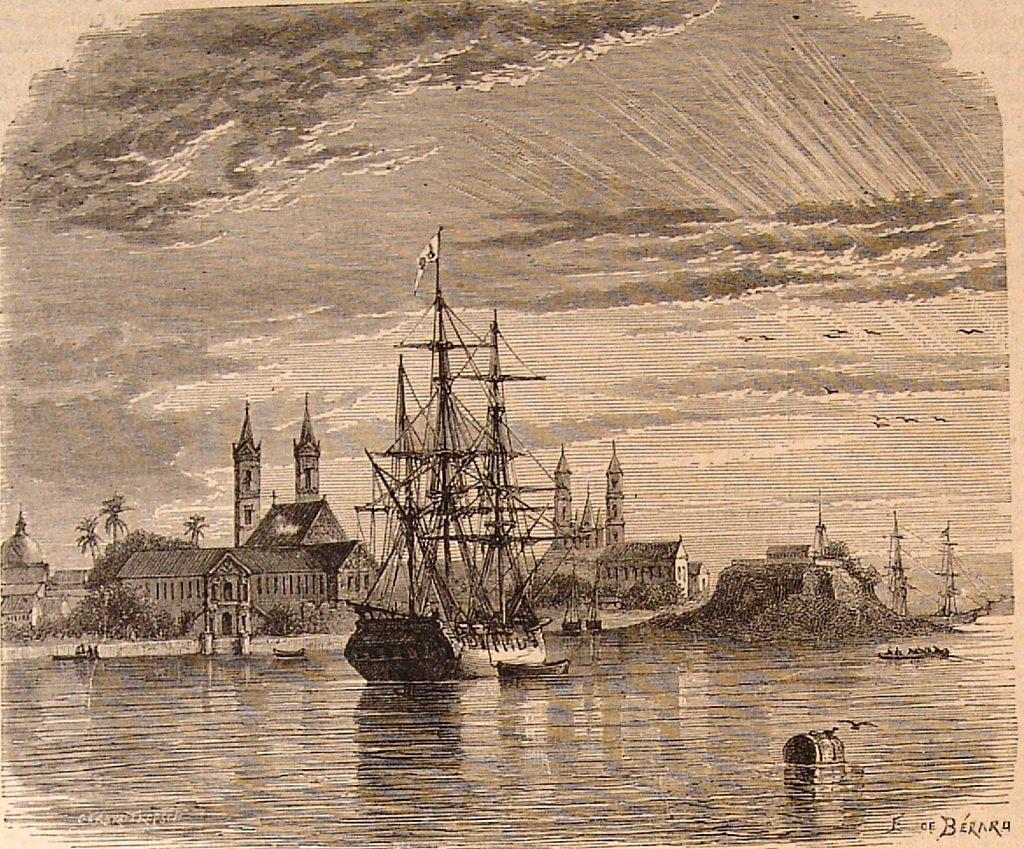What is depicted on the paper in the image? There is a drawing on a paper in the image. What type of hat is the maid wearing in the image? There is no maid or hat present in the image; it only features a drawing on a paper. 